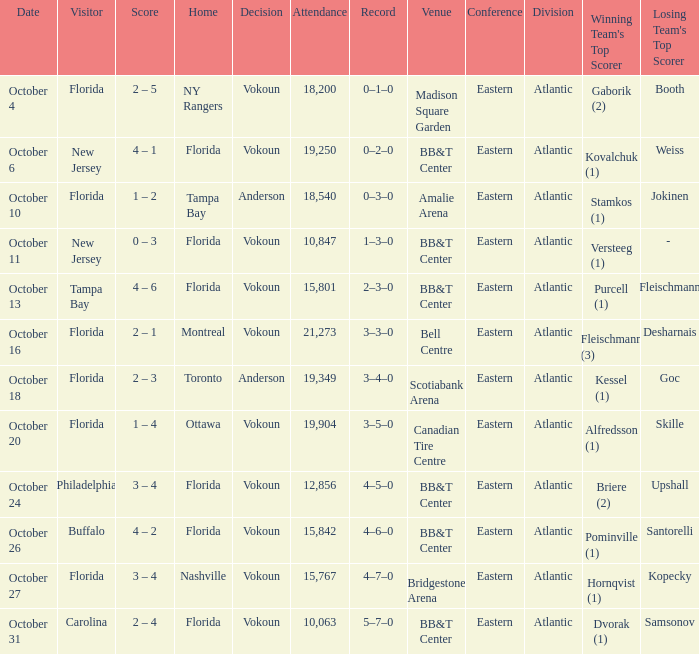Which team was at home on october 13? Florida. 